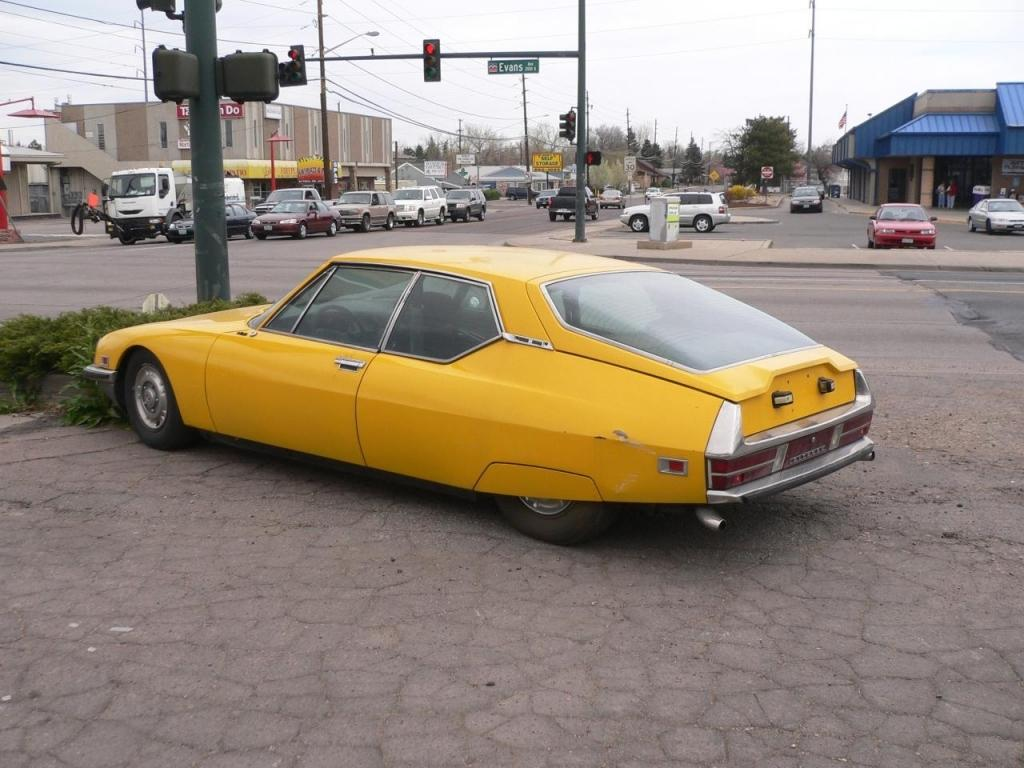What can be seen on the road in the image? There are vehicles on the road in the image. What structures are present in the image besides vehicles? There are poles, traffic lights, sign boards, trees, and buildings in the image. What is the rate at which the rock is spinning in the image? There is no rock present in the image, so it is not possible to determine the rate at which it might be spinning. 